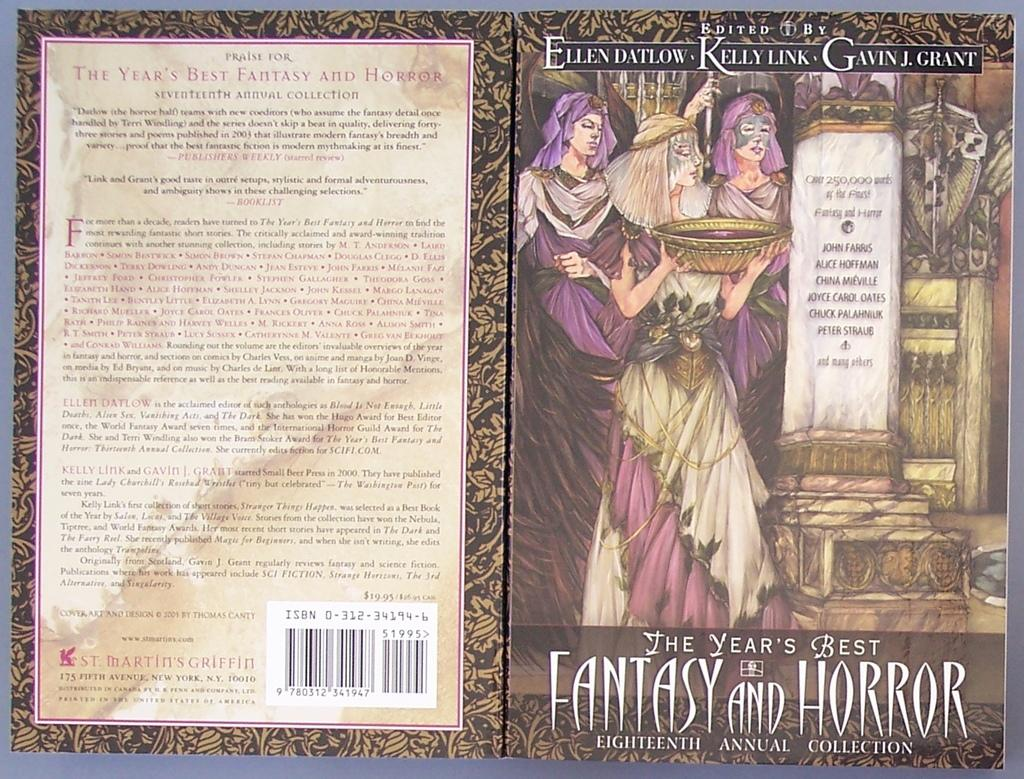<image>
Give a short and clear explanation of the subsequent image. a book of fantasy and horror and the description in the back part 